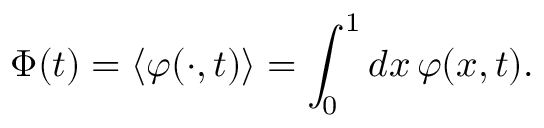Convert formula to latex. <formula><loc_0><loc_0><loc_500><loc_500>{ \Phi } ( t ) = \left \langle \varphi ( \cdot , t ) \right \rangle = \int _ { 0 } ^ { 1 } d x \, \varphi ( x , t ) .</formula> 